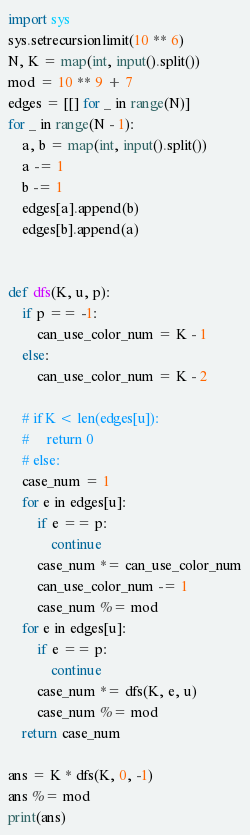<code> <loc_0><loc_0><loc_500><loc_500><_Python_>import sys
sys.setrecursionlimit(10 ** 6)
N, K = map(int, input().split())
mod = 10 ** 9 + 7
edges = [[] for _ in range(N)]
for _ in range(N - 1):
    a, b = map(int, input().split())
    a -= 1
    b -= 1
    edges[a].append(b)
    edges[b].append(a)


def dfs(K, u, p):
    if p == -1:
        can_use_color_num = K - 1
    else:
        can_use_color_num = K - 2

    # if K < len(edges[u]):
    #     return 0
    # else:
    case_num = 1
    for e in edges[u]:
        if e == p:
            continue
        case_num *= can_use_color_num
        can_use_color_num -= 1
        case_num %= mod
    for e in edges[u]:
        if e == p:
            continue
        case_num *= dfs(K, e, u)
        case_num %= mod
    return case_num

ans = K * dfs(K, 0, -1)
ans %= mod
print(ans)</code> 